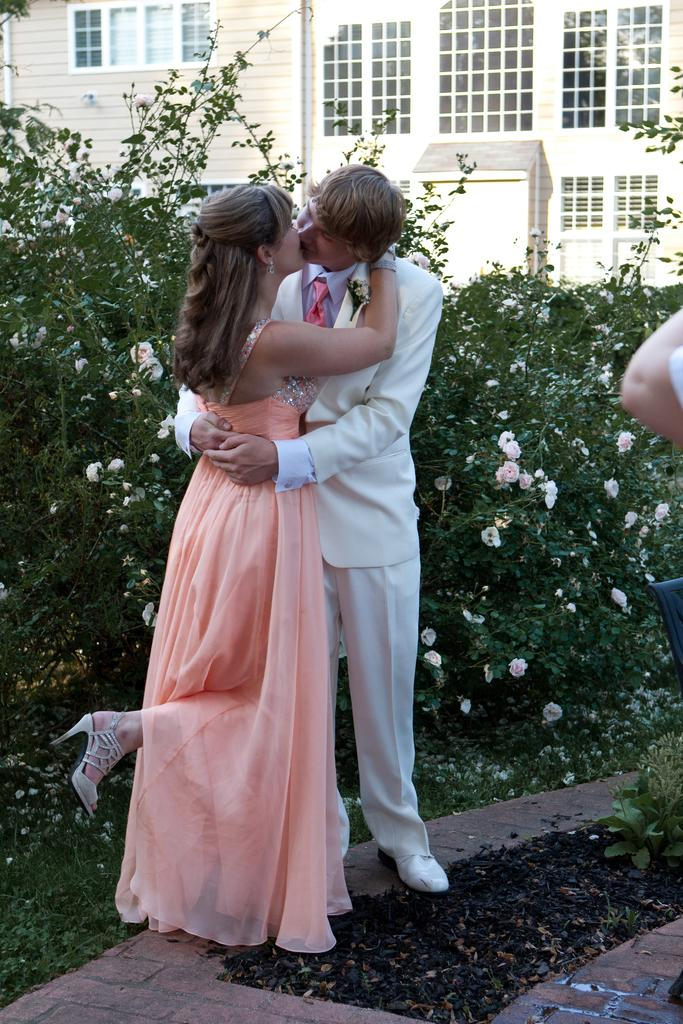How many people are in the image? There are two persons in the image. What are the two persons doing in the image? The two persons are hugging each other and kissing. What is the ground made of in the image? There is green grass at the bottom of the image. What can be seen in the background of the image? There is a building and plants in the background of the image. What type of copper pipe can be seen in the image? There is no copper pipe present in the image. 